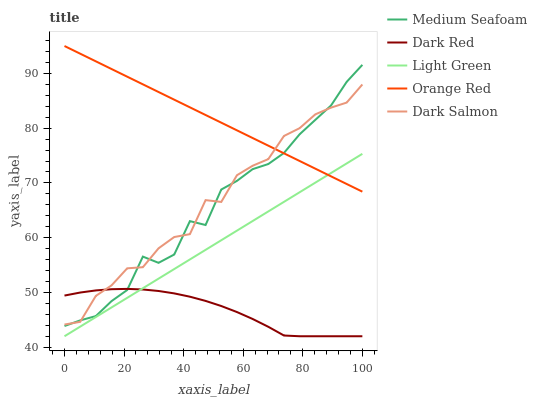Does Dark Red have the minimum area under the curve?
Answer yes or no. Yes. Does Orange Red have the maximum area under the curve?
Answer yes or no. Yes. Does Dark Salmon have the minimum area under the curve?
Answer yes or no. No. Does Dark Salmon have the maximum area under the curve?
Answer yes or no. No. Is Light Green the smoothest?
Answer yes or no. Yes. Is Dark Salmon the roughest?
Answer yes or no. Yes. Is Medium Seafoam the smoothest?
Answer yes or no. No. Is Medium Seafoam the roughest?
Answer yes or no. No. Does Dark Red have the lowest value?
Answer yes or no. Yes. Does Dark Salmon have the lowest value?
Answer yes or no. No. Does Orange Red have the highest value?
Answer yes or no. Yes. Does Dark Salmon have the highest value?
Answer yes or no. No. Is Light Green less than Medium Seafoam?
Answer yes or no. Yes. Is Dark Salmon greater than Light Green?
Answer yes or no. Yes. Does Light Green intersect Dark Red?
Answer yes or no. Yes. Is Light Green less than Dark Red?
Answer yes or no. No. Is Light Green greater than Dark Red?
Answer yes or no. No. Does Light Green intersect Medium Seafoam?
Answer yes or no. No. 